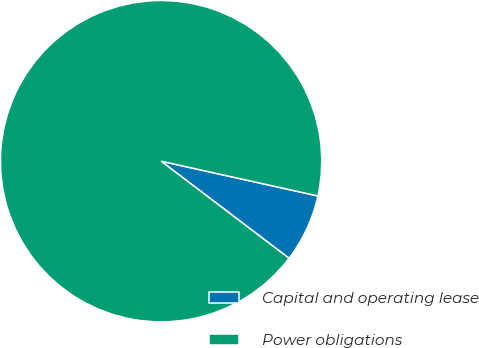<chart> <loc_0><loc_0><loc_500><loc_500><pie_chart><fcel>Capital and operating lease<fcel>Power obligations<nl><fcel>6.86%<fcel>93.14%<nl></chart> 